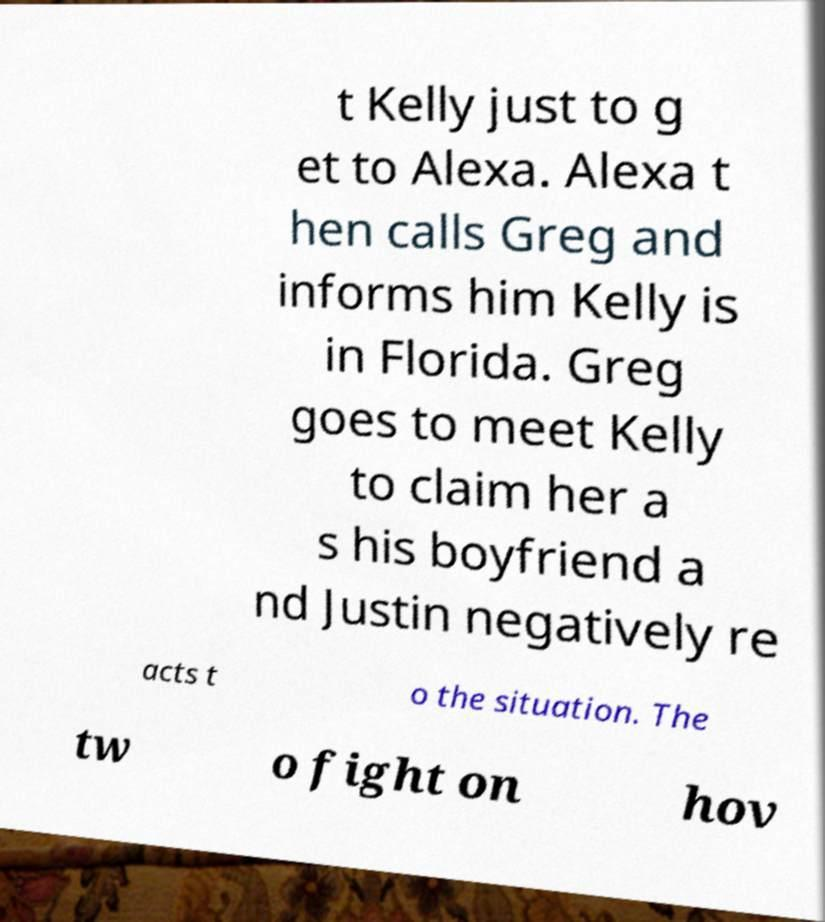Please identify and transcribe the text found in this image. t Kelly just to g et to Alexa. Alexa t hen calls Greg and informs him Kelly is in Florida. Greg goes to meet Kelly to claim her a s his boyfriend a nd Justin negatively re acts t o the situation. The tw o fight on hov 